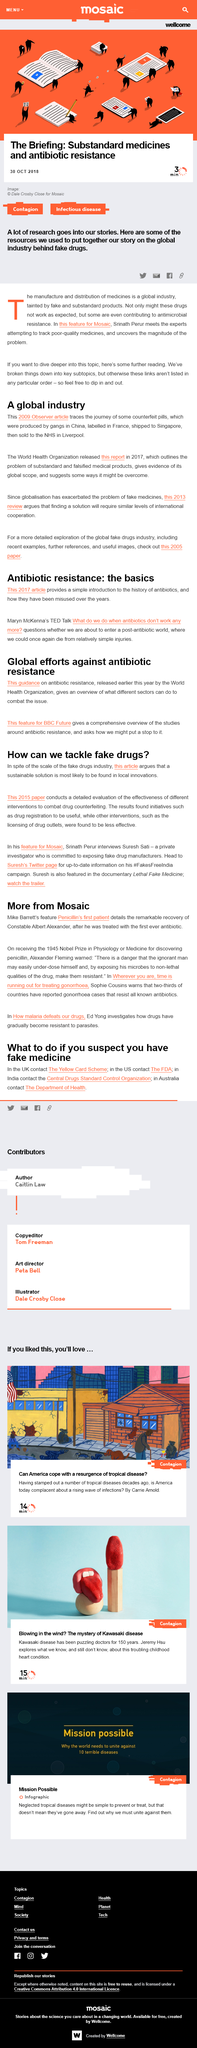Indicate a few pertinent items in this graphic. The 2015 paper conducts an extensive evaluation of the effectiveness of various interventions to combat drug counterfeiting. The World Health Organization (WHO) is supporting global efforts against antibiotic resistance, and it has provided an overview of how different sectors can combat antibiotic resistance. The following article is tagged with "Contagion" and "Infectious disease. This article was written on October 30th, 2018. The TED talk given by Maryn McKenna is titled "What do we do when antibiotics don't work anymore? 